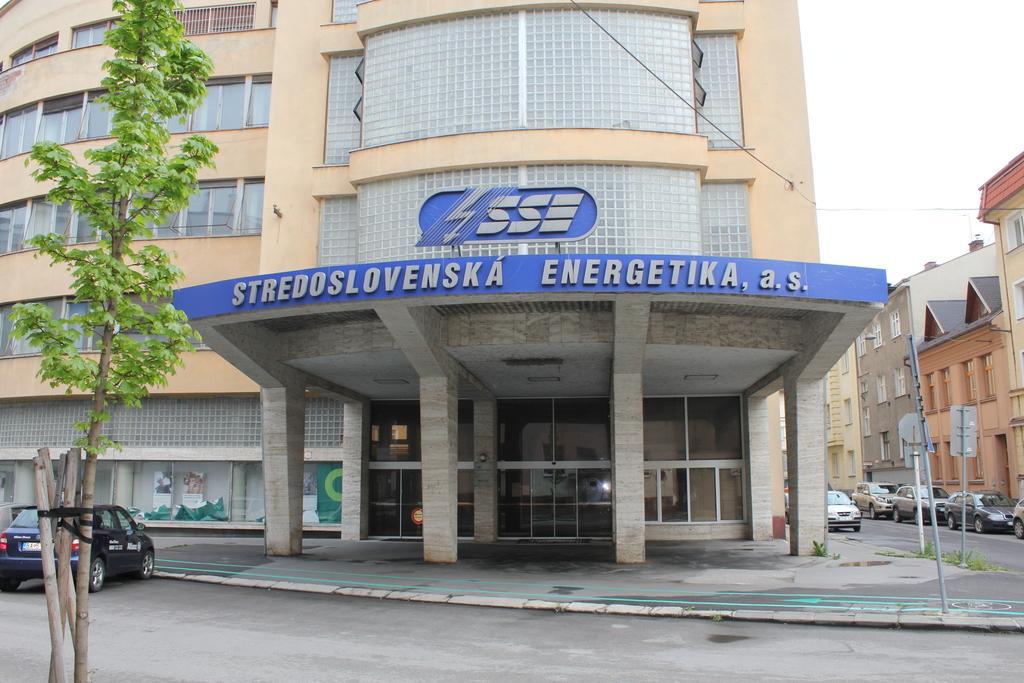Please provide a concise description of this image. In this image there is a building in the middle. On the right side there is a road on which there are so many cars. On the left side there is a car in front of the building. On the left side bottom there is a tree. At the top there is the sky. Beside the road there are buildings. 